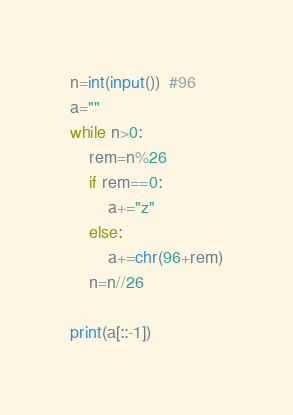<code> <loc_0><loc_0><loc_500><loc_500><_Python_>n=int(input())  #96
a=""
while n>0:
    rem=n%26
    if rem==0:
        a+="z"
    else:
        a+=chr(96+rem)
    n=n//26

print(a[::-1])


</code> 